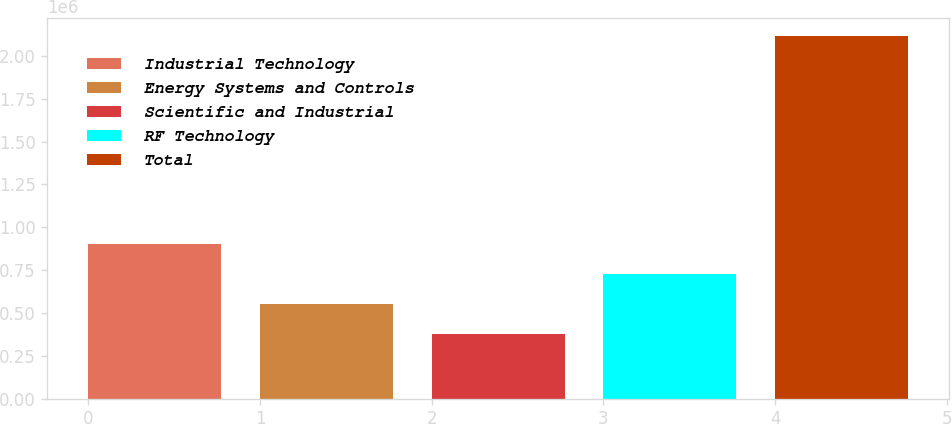Convert chart. <chart><loc_0><loc_0><loc_500><loc_500><bar_chart><fcel>Industrial Technology<fcel>Energy Systems and Controls<fcel>Scientific and Industrial<fcel>RF Technology<fcel>Total<nl><fcel>899757<fcel>551688<fcel>377653<fcel>725722<fcel>2.118e+06<nl></chart> 